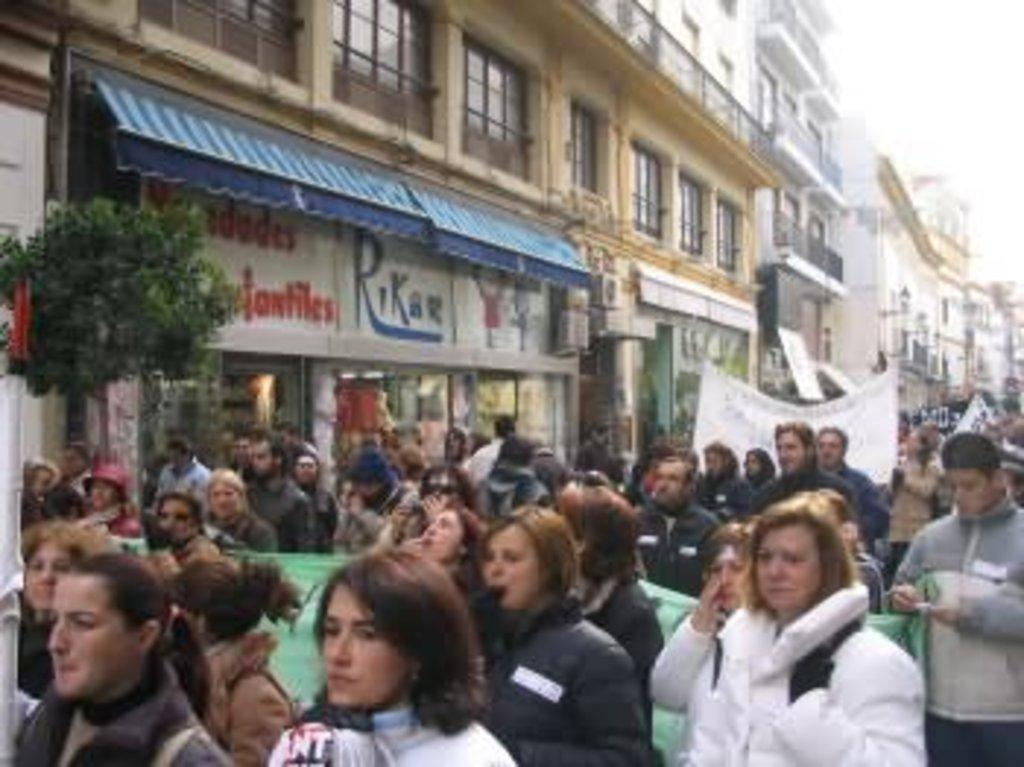What type of structures can be seen in the image? There are buildings in the image. What feature is visible on the buildings? There are windows visible in the image. What other elements can be seen in the image? There are trees, stores, and a group of people walking in the image. What are some people in the group doing? Some people are holding banners. How would you describe the color of the sky in the image? The sky is in white color. What type of shoes can be seen on the trees in the image? There are no shoes visible on the trees in the image; only trees are present. What books are people reading while walking in the image? There are no books visible in the image; people are walking and holding banners. 